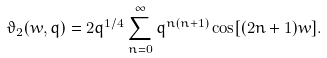Convert formula to latex. <formula><loc_0><loc_0><loc_500><loc_500>\vartheta _ { 2 } ( w , q ) = 2 q ^ { 1 / 4 } \sum _ { n = 0 } ^ { \infty } q ^ { n ( n + 1 ) } \cos [ ( 2 n + 1 ) w ] .</formula> 